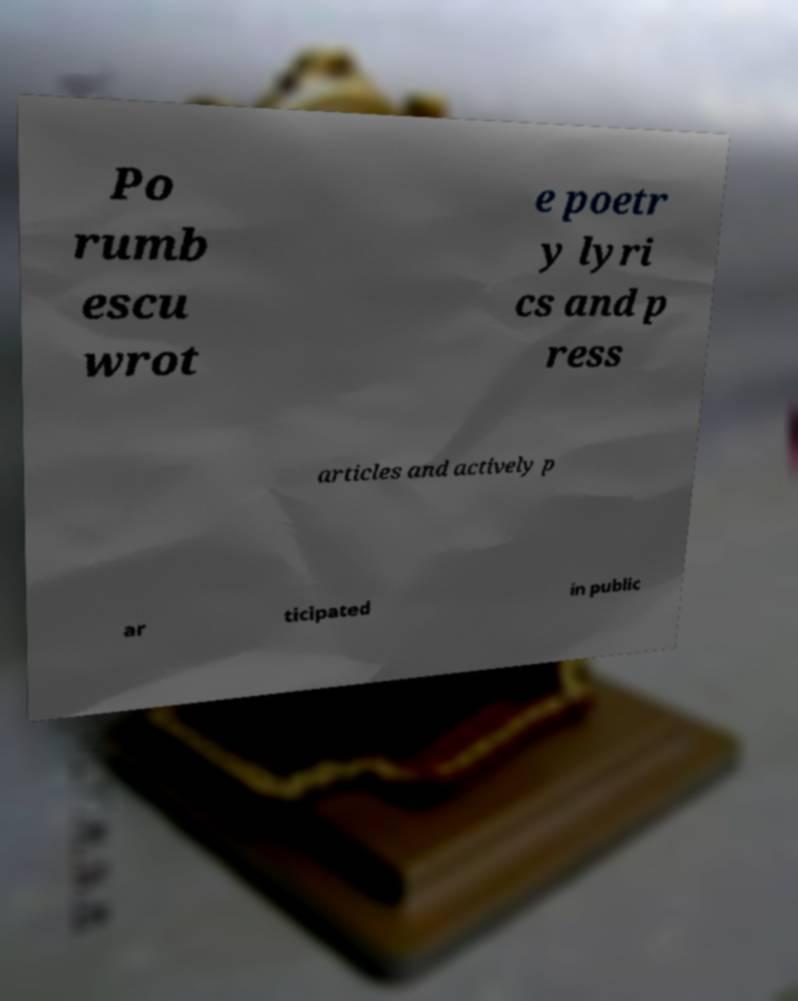Could you extract and type out the text from this image? Po rumb escu wrot e poetr y lyri cs and p ress articles and actively p ar ticipated in public 